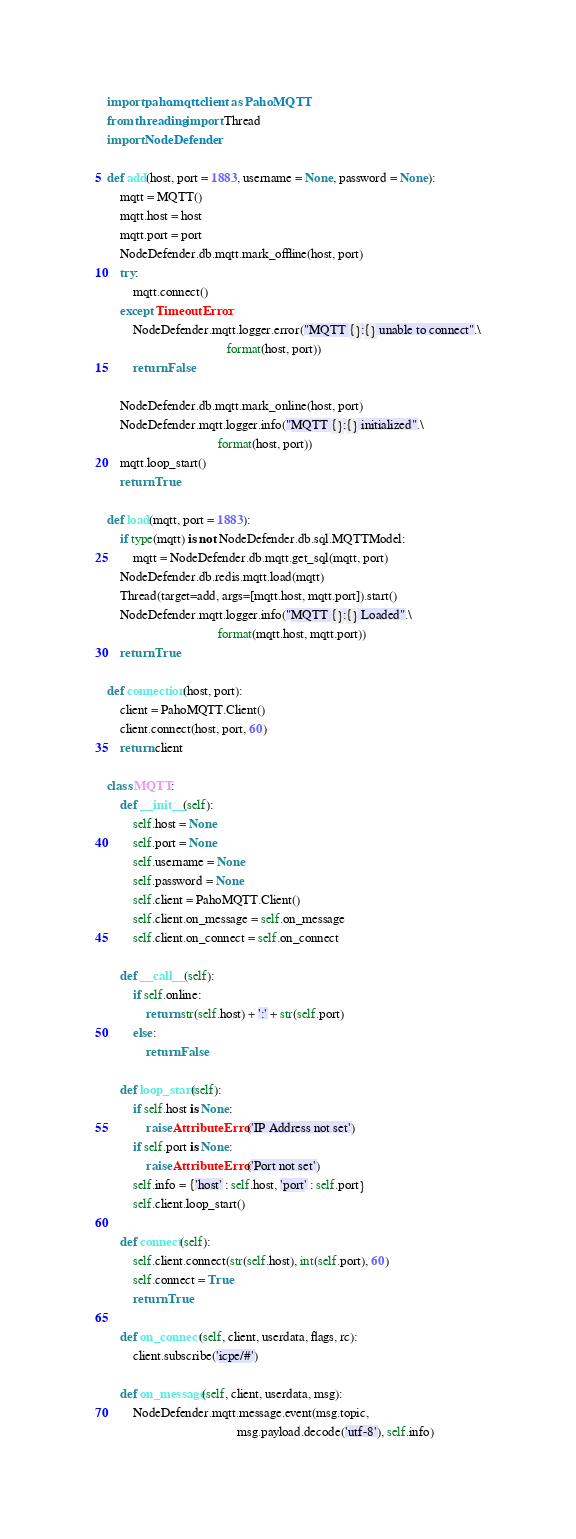<code> <loc_0><loc_0><loc_500><loc_500><_Python_>import paho.mqtt.client as PahoMQTT
from threading import Thread
import NodeDefender

def add(host, port = 1883, username = None, password = None):
    mqtt = MQTT()
    mqtt.host = host
    mqtt.port = port
    NodeDefender.db.mqtt.mark_offline(host, port)
    try:
        mqtt.connect()
    except TimeoutError:
        NodeDefender.mqtt.logger.error("MQTT {}:{} unable to connect".\
                                     format(host, port))
        return False

    NodeDefender.db.mqtt.mark_online(host, port)
    NodeDefender.mqtt.logger.info("MQTT {}:{} initialized".\
                                  format(host, port))
    mqtt.loop_start()
    return True

def load(mqtt, port = 1883):
    if type(mqtt) is not NodeDefender.db.sql.MQTTModel:
        mqtt = NodeDefender.db.mqtt.get_sql(mqtt, port)
    NodeDefender.db.redis.mqtt.load(mqtt)
    Thread(target=add, args=[mqtt.host, mqtt.port]).start()
    NodeDefender.mqtt.logger.info("MQTT {}:{} Loaded".\
                                  format(mqtt.host, mqtt.port))
    return True

def connection(host, port):
    client = PahoMQTT.Client()
    client.connect(host, port, 60)
    return client

class MQTT:
    def __init__(self):
        self.host = None
        self.port = None
        self.username = None
        self.password = None
        self.client = PahoMQTT.Client()
        self.client.on_message = self.on_message
        self.client.on_connect = self.on_connect

    def __call__(self):
        if self.online:
            return str(self.host) + ':' + str(self.port)
        else:
            return False

    def loop_start(self):
        if self.host is None:
            raise AttributeError('IP Address not set')
        if self.port is None:
            raise AttributeError('Port not set')
        self.info = {'host' : self.host, 'port' : self.port}
        self.client.loop_start()
    
    def connect(self):
        self.client.connect(str(self.host), int(self.port), 60)
        self.connect = True
        return True

    def on_connect(self, client, userdata, flags, rc):
        client.subscribe('icpe/#')

    def on_message(self, client, userdata, msg):
        NodeDefender.mqtt.message.event(msg.topic,
                                        msg.payload.decode('utf-8'), self.info)
</code> 